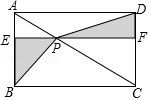Narrate what you see in the visual. In the given diagram, there is a rectangle named ABCD. The diagonal AC has a point P on it. Two parallel lines, EF and BC, are present in the diagram. The points where EF intersects with AB and CD are called E and F, respectively. The diagram includes rectangles AEPM, DFPM, CFPN, and BEPN. 